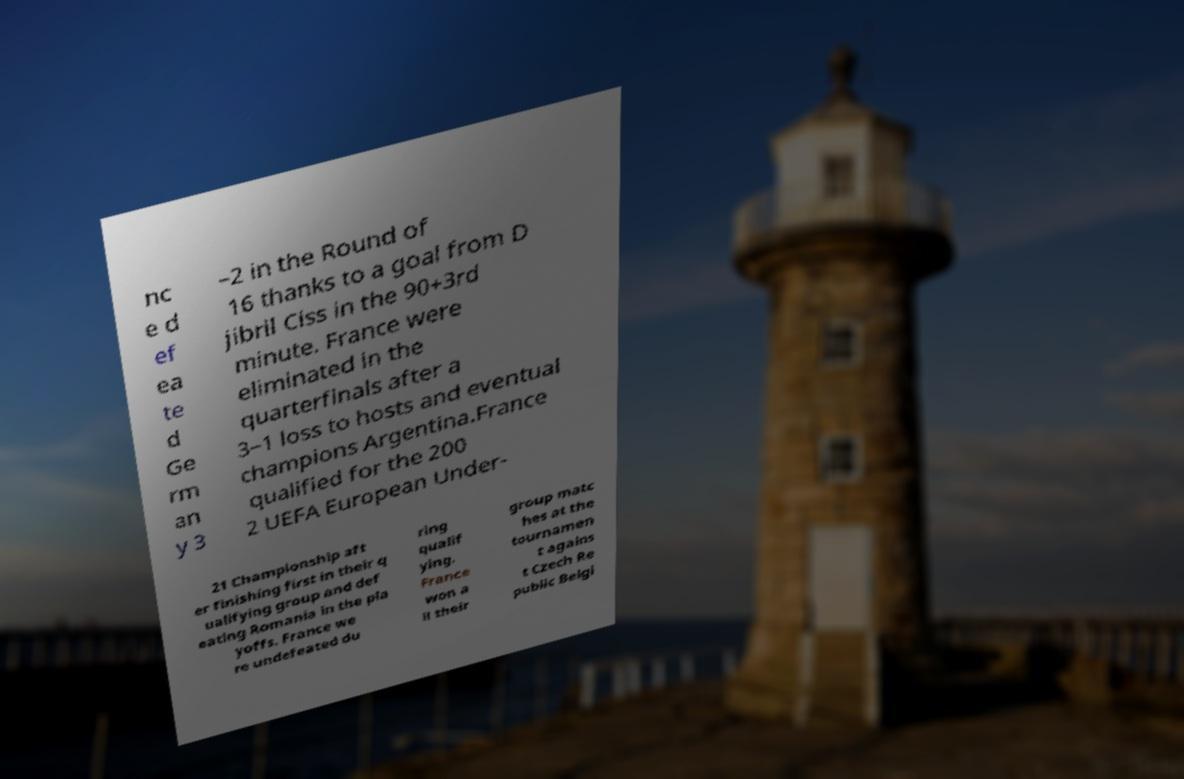I need the written content from this picture converted into text. Can you do that? nc e d ef ea te d Ge rm an y 3 –2 in the Round of 16 thanks to a goal from D jibril Ciss in the 90+3rd minute. France were eliminated in the quarterfinals after a 3–1 loss to hosts and eventual champions Argentina.France qualified for the 200 2 UEFA European Under- 21 Championship aft er finishing first in their q ualifying group and def eating Romania in the pla yoffs. France we re undefeated du ring qualif ying. France won a ll their group matc hes at the tournamen t agains t Czech Re public Belgi 